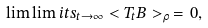Convert formula to latex. <formula><loc_0><loc_0><loc_500><loc_500>\lim \lim i t s _ { t \to \infty } < T _ { t } B > _ { \rho } \, = \, 0 ,</formula> 